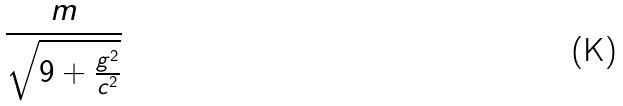<formula> <loc_0><loc_0><loc_500><loc_500>\frac { m } { \sqrt { 9 + \frac { g ^ { 2 } } { c ^ { 2 } } } }</formula> 